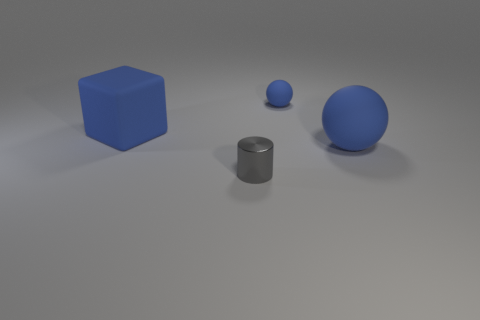Subtract 1 cubes. How many cubes are left? 0 Add 2 cyan metallic objects. How many objects exist? 6 Subtract all blue shiny objects. Subtract all rubber things. How many objects are left? 1 Add 4 big blue rubber cubes. How many big blue rubber cubes are left? 5 Add 1 big blue matte things. How many big blue matte things exist? 3 Subtract 0 brown cylinders. How many objects are left? 4 Subtract all cylinders. How many objects are left? 3 Subtract all purple cylinders. Subtract all cyan cubes. How many cylinders are left? 1 Subtract all brown cubes. How many purple spheres are left? 0 